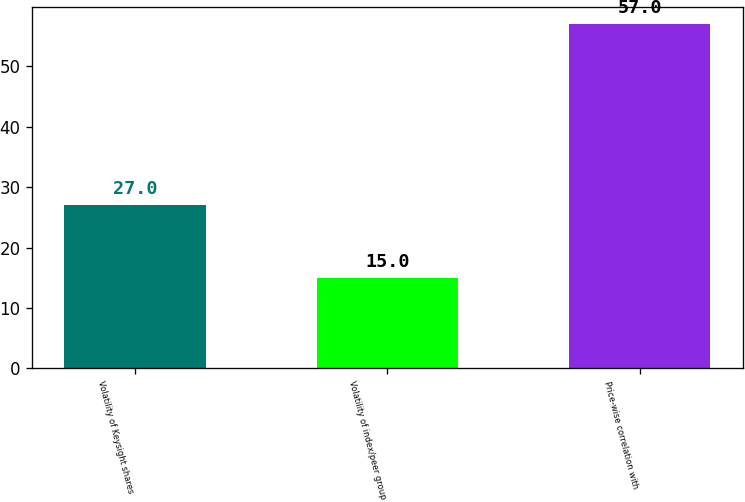Convert chart to OTSL. <chart><loc_0><loc_0><loc_500><loc_500><bar_chart><fcel>Volatility of Keysight shares<fcel>Volatility of index/peer group<fcel>Price-wise correlation with<nl><fcel>27<fcel>15<fcel>57<nl></chart> 